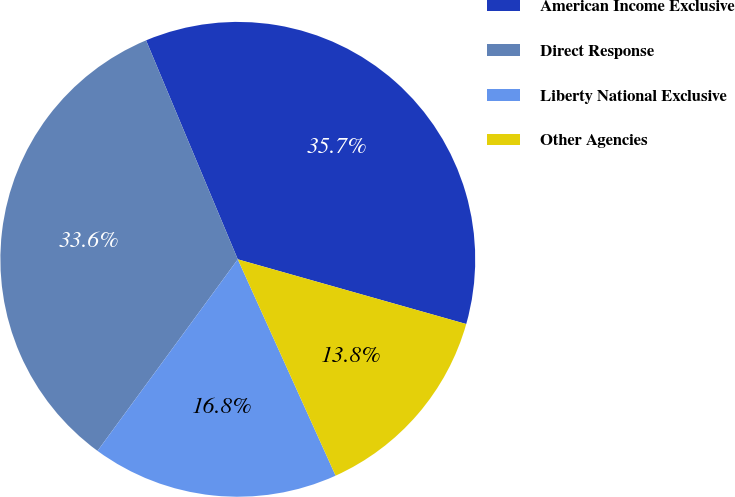Convert chart to OTSL. <chart><loc_0><loc_0><loc_500><loc_500><pie_chart><fcel>American Income Exclusive<fcel>Direct Response<fcel>Liberty National Exclusive<fcel>Other Agencies<nl><fcel>35.71%<fcel>33.63%<fcel>16.82%<fcel>13.85%<nl></chart> 